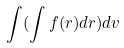<formula> <loc_0><loc_0><loc_500><loc_500>\int ( \int f ( r ) d r ) d v</formula> 